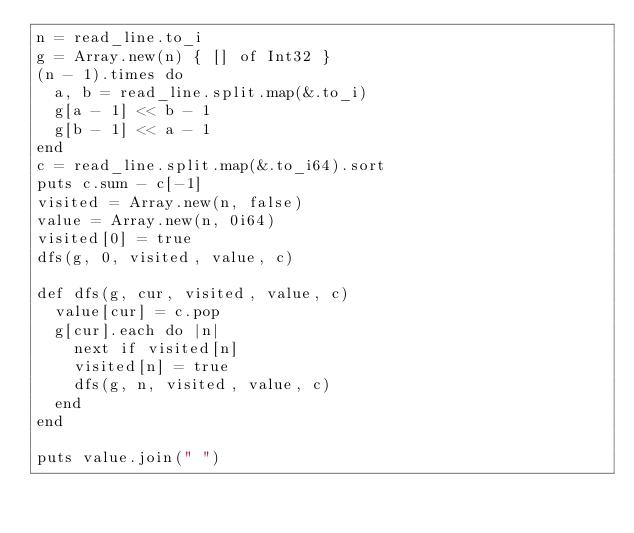<code> <loc_0><loc_0><loc_500><loc_500><_Crystal_>n = read_line.to_i
g = Array.new(n) { [] of Int32 }
(n - 1).times do
  a, b = read_line.split.map(&.to_i)
  g[a - 1] << b - 1
  g[b - 1] << a - 1
end
c = read_line.split.map(&.to_i64).sort
puts c.sum - c[-1]
visited = Array.new(n, false)
value = Array.new(n, 0i64)
visited[0] = true
dfs(g, 0, visited, value, c)

def dfs(g, cur, visited, value, c)
  value[cur] = c.pop
  g[cur].each do |n|
    next if visited[n]
    visited[n] = true
    dfs(g, n, visited, value, c)
  end
end

puts value.join(" ")
</code> 